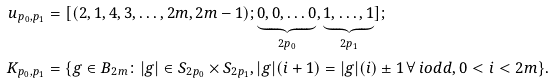<formula> <loc_0><loc_0><loc_500><loc_500>u _ { p _ { 0 } , p _ { 1 } } & = [ ( 2 , 1 , 4 , 3 , \dots , 2 m , 2 m - 1 ) ; \underbrace { 0 , 0 , \dots 0 } _ { 2 p _ { 0 } } , \underbrace { 1 , \dots , 1 } _ { 2 p _ { 1 } } ] ; \\ K _ { p _ { 0 } , p _ { 1 } } & = \{ g \in B _ { 2 m } \colon | g | \in S _ { 2 p _ { 0 } } \times S _ { 2 p _ { 1 } } , | g | ( i + 1 ) = | g | ( i ) \pm 1 \, \forall \, i o d d , 0 < i < 2 m \} .</formula> 